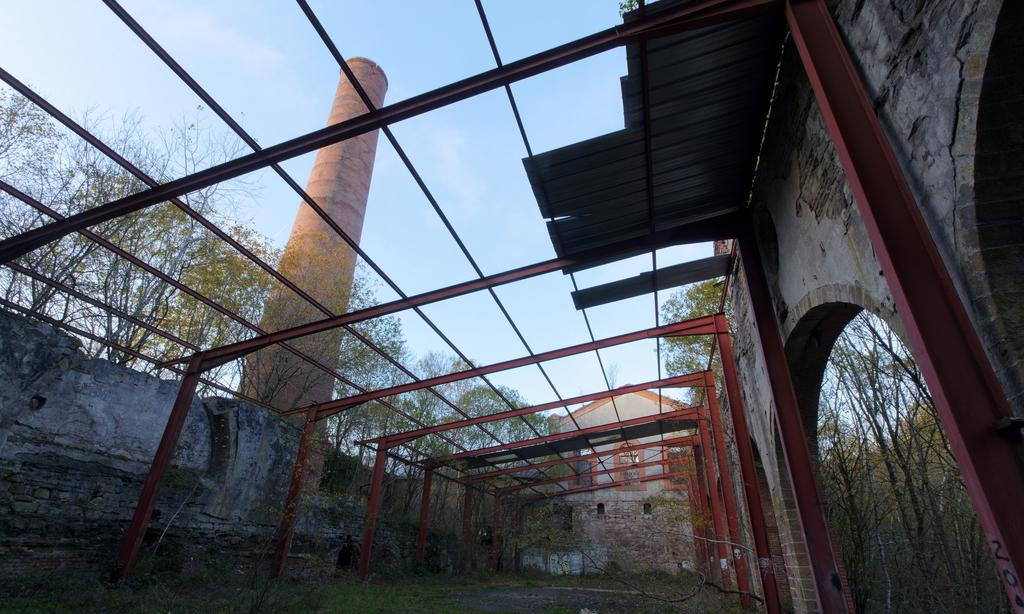What type of structure can be seen in the image? There is a wall, rods, a tower, and a roof visible in the image. What type of vegetation is present in the image? There are trees in the image. What is at the bottom of the image? There is grass and ground at the bottom of the image. What is visible at the top of the image? The sky is visible at the top of the image. Can you see a rifle being used by someone in the image? There is no rifle or person using a rifle present in the image. How does the tower maintain its balance in the image? The tower does not need to maintain its balance in the image, as it is a static structure. 